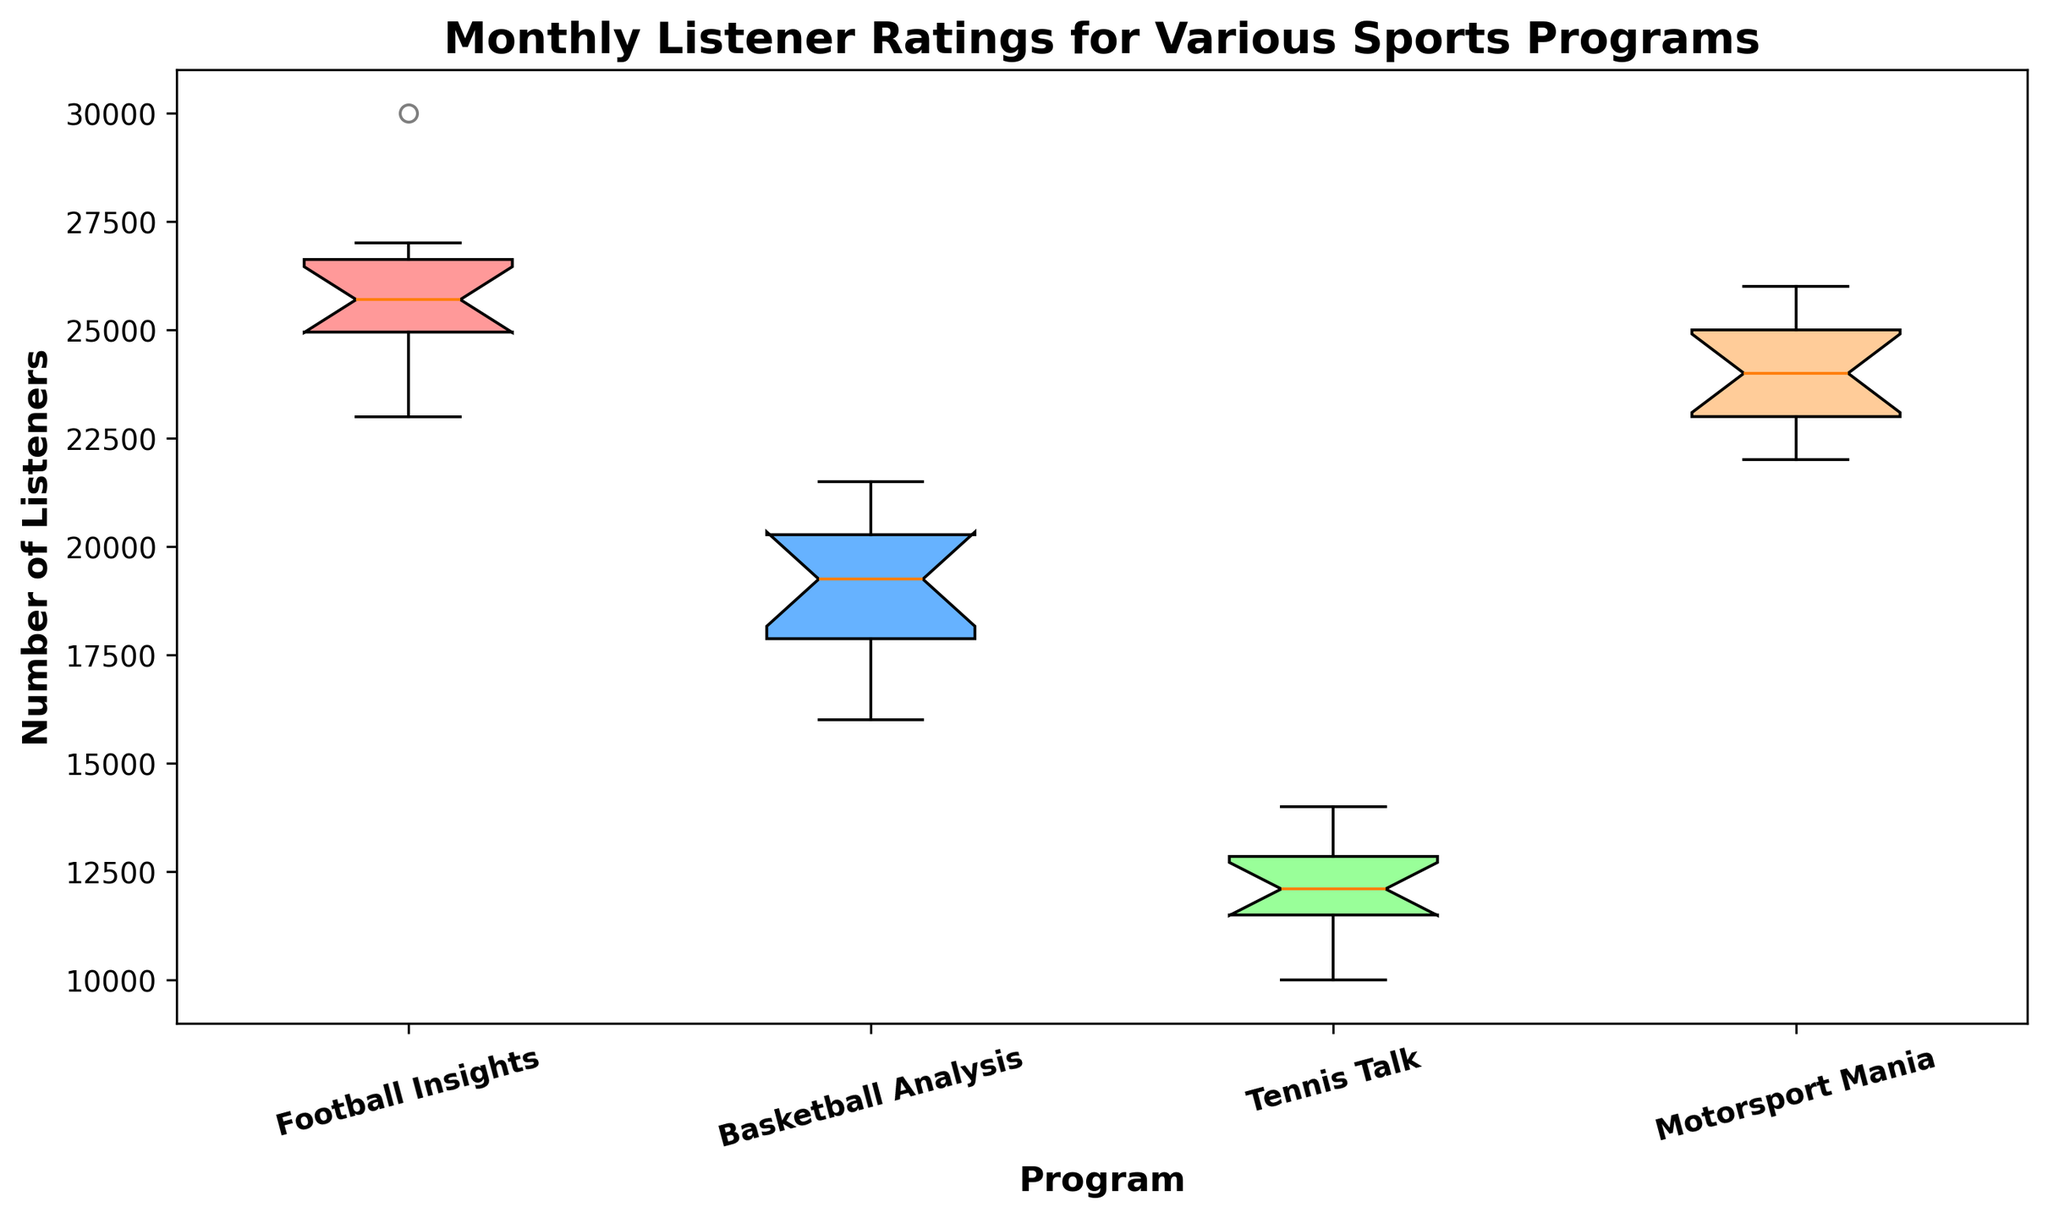How does the median number of listeners compare among the various sports programs? To determine the median, look for the middle line within each box plot. Football Insights has the highest median, followed by Motorsport Mania, Basketball Analysis, and Tennis Talk having the lowest median.
Answer: Football Insights > Motorsport Mania > Basketball Analysis > Tennis Talk Which sports program has the widest interquartile range (IQR)? The IQR is the distance between the top and bottom of the box. Motorsport Mania seems to have the widest box, indicating the largest IQR.
Answer: Motorsport Mania Are there any outliers in the Monthly Listener Ratings? If so, for which programs? Outliers are the points that fall outside the whiskers. Only Football Insights has an outlier, which appears as a point above the main plot area.
Answer: Football Insights Which sports program had the most consistent listener ratings throughout the year? Consistency is shown by the narrowness of the box representing the IQR and the lengths of the whiskers. Tennis Talk has the narrowest box and relatively short whiskers, indicating the most consistent ratings.
Answer: Tennis Talk What is the total upper quartile (Q3) listeners for Football Insights and Basketball Analysis? The upper quartile (Q3) is the top edge of the box. Sum the values of Q3 for Football Insights (approximately 26750) and Basketball Analysis (approximately 20750).
Answer: 47500 Does any program have overlapping interquartile ranges with another program? Overlapping IQRs are seen if the boxes of different programs overlap. Motorsport Mania and Basketball Analysis have overlapping IQRs.
Answer: Yes, Motorsport Mania and Basketball Analysis How does the spread of listener ratings for Tennis Talk compare to Basketball Analysis? The spread can be measured by the length of the whiskers. Tennis Talk has shorter whiskers compared to Basketball Analysis, indicating a smaller spread.
Answer: Smaller Which program had the highest single-month listener count? The highest data point in the plot represents the highest single-month listener count. The highest point belongs to Football Insights' outlier.
Answer: Football Insights Estimate the interquartile range (IQR) for Motorsport Mania. The IQR is the distance between Q1 and Q3. The box for Motorsport Mania starts around 23000 (Q1) and goes up to around 25000 (Q3). So, 25000 - 23000 = 2000.
Answer: 2000 